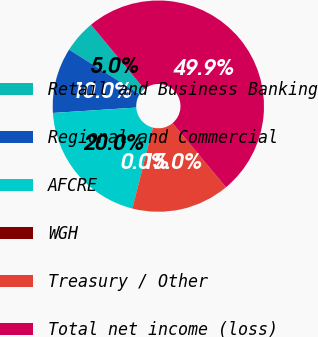<chart> <loc_0><loc_0><loc_500><loc_500><pie_chart><fcel>Retail and Business Banking<fcel>Regional and Commercial<fcel>AFCRE<fcel>WGH<fcel>Treasury / Other<fcel>Total net income (loss)<nl><fcel>5.02%<fcel>10.01%<fcel>19.99%<fcel>0.03%<fcel>15.0%<fcel>49.94%<nl></chart> 